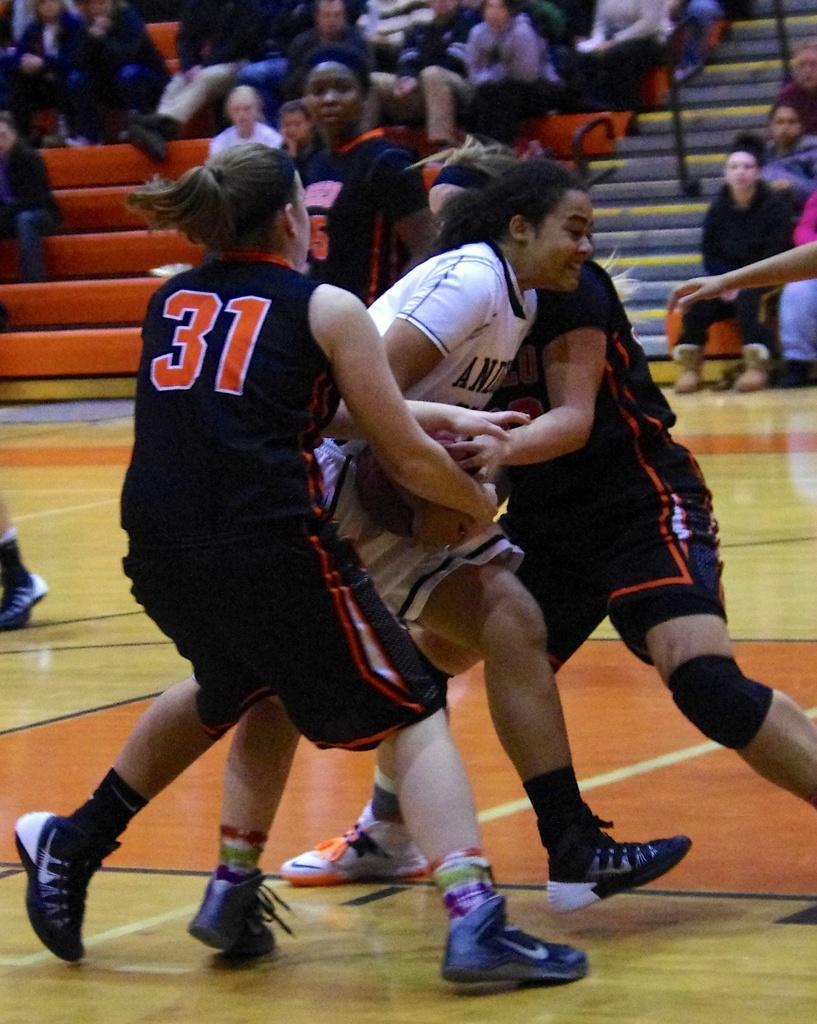In one or two sentences, can you explain what this image depicts? In this image I can see there are three women's standing on the ground and they are playing a game and a woman standing on the ground in the middle and there are few persons sitting on staircase at the top. 